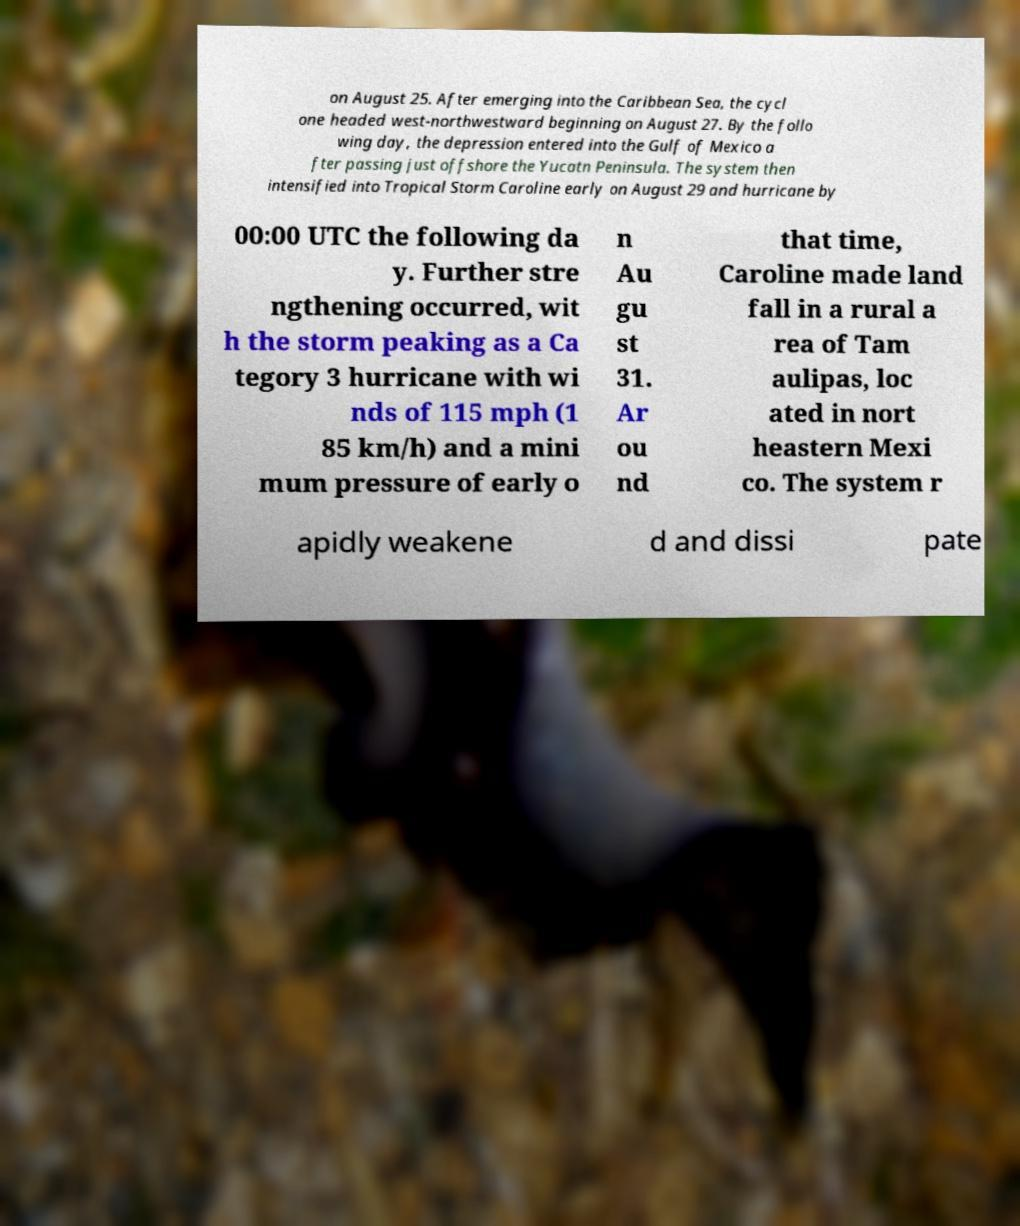I need the written content from this picture converted into text. Can you do that? on August 25. After emerging into the Caribbean Sea, the cycl one headed west-northwestward beginning on August 27. By the follo wing day, the depression entered into the Gulf of Mexico a fter passing just offshore the Yucatn Peninsula. The system then intensified into Tropical Storm Caroline early on August 29 and hurricane by 00:00 UTC the following da y. Further stre ngthening occurred, wit h the storm peaking as a Ca tegory 3 hurricane with wi nds of 115 mph (1 85 km/h) and a mini mum pressure of early o n Au gu st 31. Ar ou nd that time, Caroline made land fall in a rural a rea of Tam aulipas, loc ated in nort heastern Mexi co. The system r apidly weakene d and dissi pate 